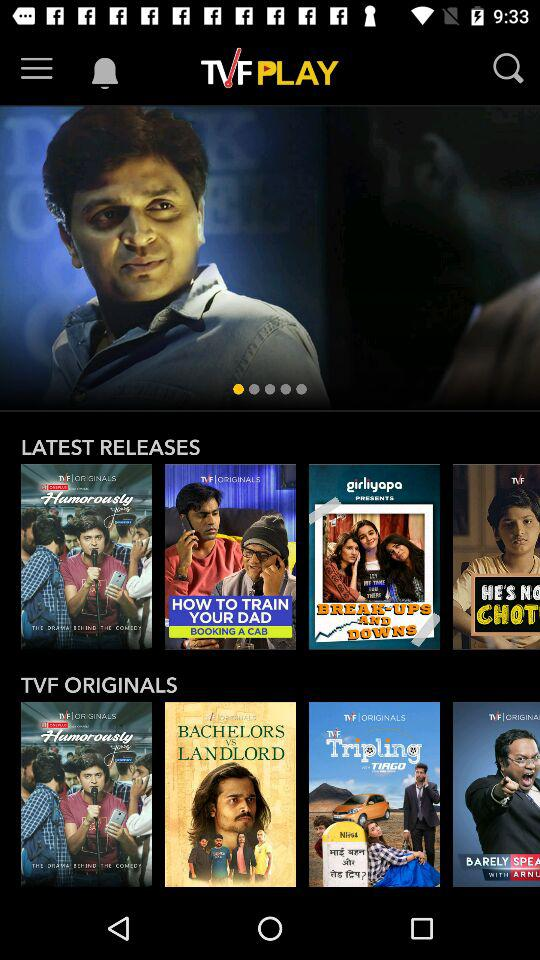What is the application name? The application name is "TVF PLAY". 